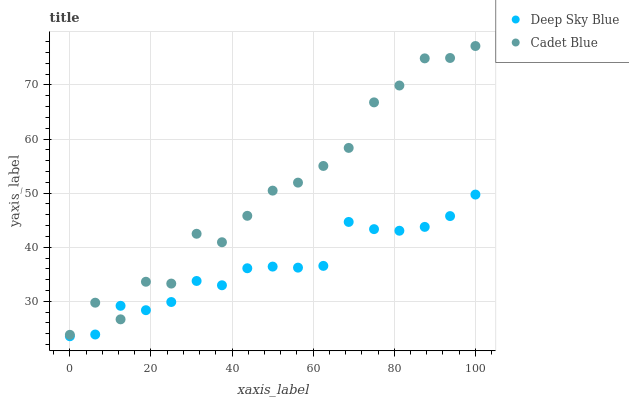Does Deep Sky Blue have the minimum area under the curve?
Answer yes or no. Yes. Does Cadet Blue have the maximum area under the curve?
Answer yes or no. Yes. Does Deep Sky Blue have the maximum area under the curve?
Answer yes or no. No. Is Deep Sky Blue the smoothest?
Answer yes or no. Yes. Is Cadet Blue the roughest?
Answer yes or no. Yes. Is Deep Sky Blue the roughest?
Answer yes or no. No. Does Deep Sky Blue have the lowest value?
Answer yes or no. Yes. Does Cadet Blue have the highest value?
Answer yes or no. Yes. Does Deep Sky Blue have the highest value?
Answer yes or no. No. Does Cadet Blue intersect Deep Sky Blue?
Answer yes or no. Yes. Is Cadet Blue less than Deep Sky Blue?
Answer yes or no. No. Is Cadet Blue greater than Deep Sky Blue?
Answer yes or no. No. 